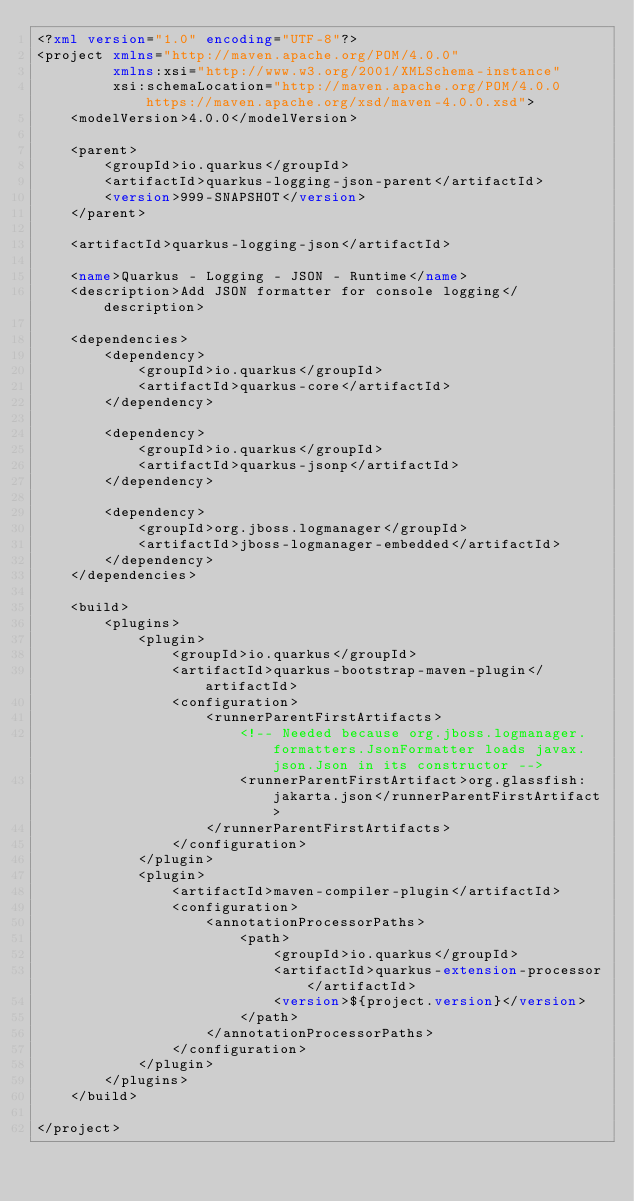Convert code to text. <code><loc_0><loc_0><loc_500><loc_500><_XML_><?xml version="1.0" encoding="UTF-8"?>
<project xmlns="http://maven.apache.org/POM/4.0.0"
         xmlns:xsi="http://www.w3.org/2001/XMLSchema-instance"
         xsi:schemaLocation="http://maven.apache.org/POM/4.0.0 https://maven.apache.org/xsd/maven-4.0.0.xsd">
    <modelVersion>4.0.0</modelVersion>

    <parent>
        <groupId>io.quarkus</groupId>
        <artifactId>quarkus-logging-json-parent</artifactId>
        <version>999-SNAPSHOT</version>
    </parent>

    <artifactId>quarkus-logging-json</artifactId>

    <name>Quarkus - Logging - JSON - Runtime</name>
    <description>Add JSON formatter for console logging</description>

    <dependencies>
        <dependency>
            <groupId>io.quarkus</groupId>
            <artifactId>quarkus-core</artifactId>
        </dependency>

        <dependency>
            <groupId>io.quarkus</groupId>
            <artifactId>quarkus-jsonp</artifactId>
        </dependency>

        <dependency>
            <groupId>org.jboss.logmanager</groupId>
            <artifactId>jboss-logmanager-embedded</artifactId>
        </dependency>
    </dependencies>

    <build>
        <plugins>
            <plugin>
                <groupId>io.quarkus</groupId>
                <artifactId>quarkus-bootstrap-maven-plugin</artifactId>
                <configuration>
                    <runnerParentFirstArtifacts>
                        <!-- Needed because org.jboss.logmanager.formatters.JsonFormatter loads javax.json.Json in its constructor -->
                        <runnerParentFirstArtifact>org.glassfish:jakarta.json</runnerParentFirstArtifact>
                    </runnerParentFirstArtifacts>
                </configuration>
            </plugin>
            <plugin>
                <artifactId>maven-compiler-plugin</artifactId>
                <configuration>
                    <annotationProcessorPaths>
                        <path>
                            <groupId>io.quarkus</groupId>
                            <artifactId>quarkus-extension-processor</artifactId>
                            <version>${project.version}</version>
                        </path>
                    </annotationProcessorPaths>
                </configuration>
            </plugin>
        </plugins>
    </build>

</project>
</code> 